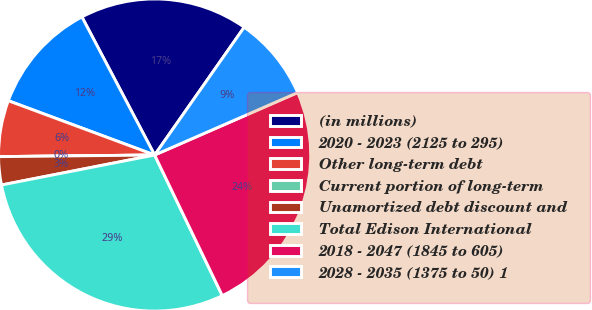Convert chart. <chart><loc_0><loc_0><loc_500><loc_500><pie_chart><fcel>(in millions)<fcel>2020 - 2023 (2125 to 295)<fcel>Other long-term debt<fcel>Current portion of long-term<fcel>Unamortized debt discount and<fcel>Total Edison International<fcel>2018 - 2047 (1845 to 605)<fcel>2028 - 2035 (1375 to 50) 1<nl><fcel>17.44%<fcel>11.63%<fcel>5.82%<fcel>0.0%<fcel>2.91%<fcel>29.06%<fcel>24.41%<fcel>8.72%<nl></chart> 